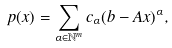Convert formula to latex. <formula><loc_0><loc_0><loc_500><loc_500>p ( x ) = \sum _ { \alpha \in \mathbb { N } ^ { m } } c _ { \alpha } ( b - A x ) ^ { \alpha } ,</formula> 